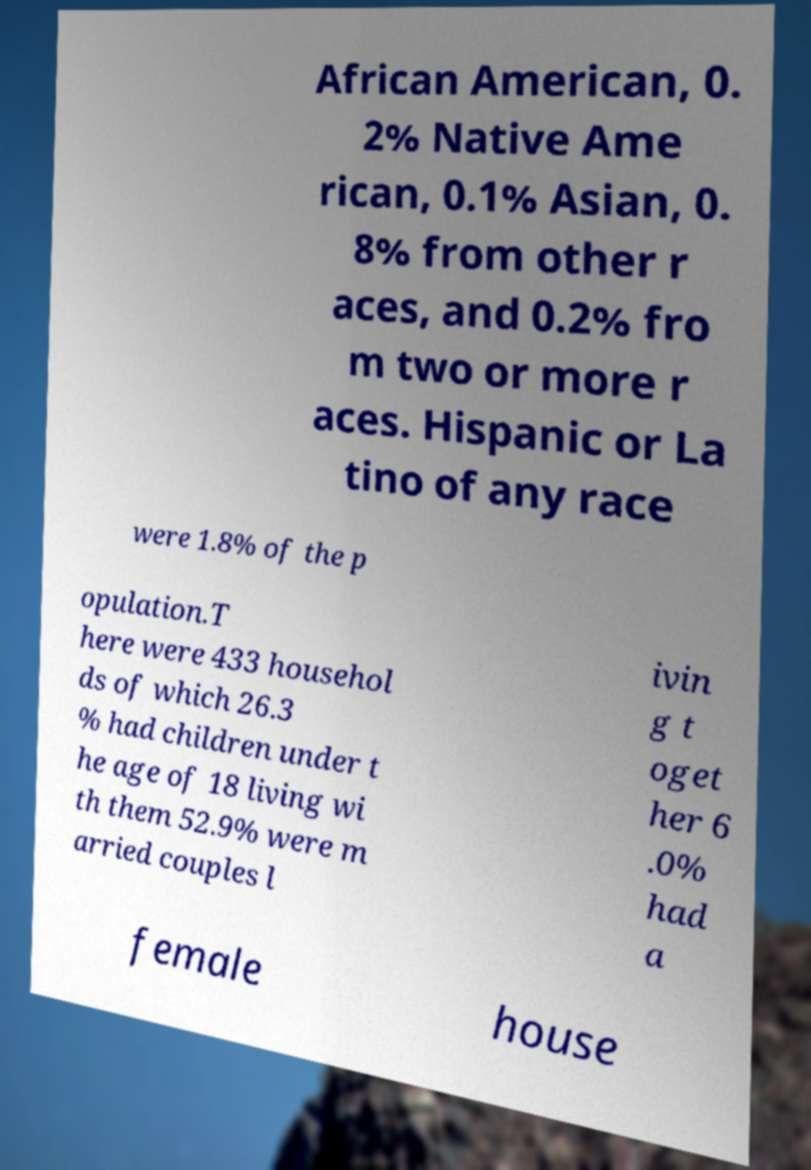Please read and relay the text visible in this image. What does it say? African American, 0. 2% Native Ame rican, 0.1% Asian, 0. 8% from other r aces, and 0.2% fro m two or more r aces. Hispanic or La tino of any race were 1.8% of the p opulation.T here were 433 househol ds of which 26.3 % had children under t he age of 18 living wi th them 52.9% were m arried couples l ivin g t oget her 6 .0% had a female house 